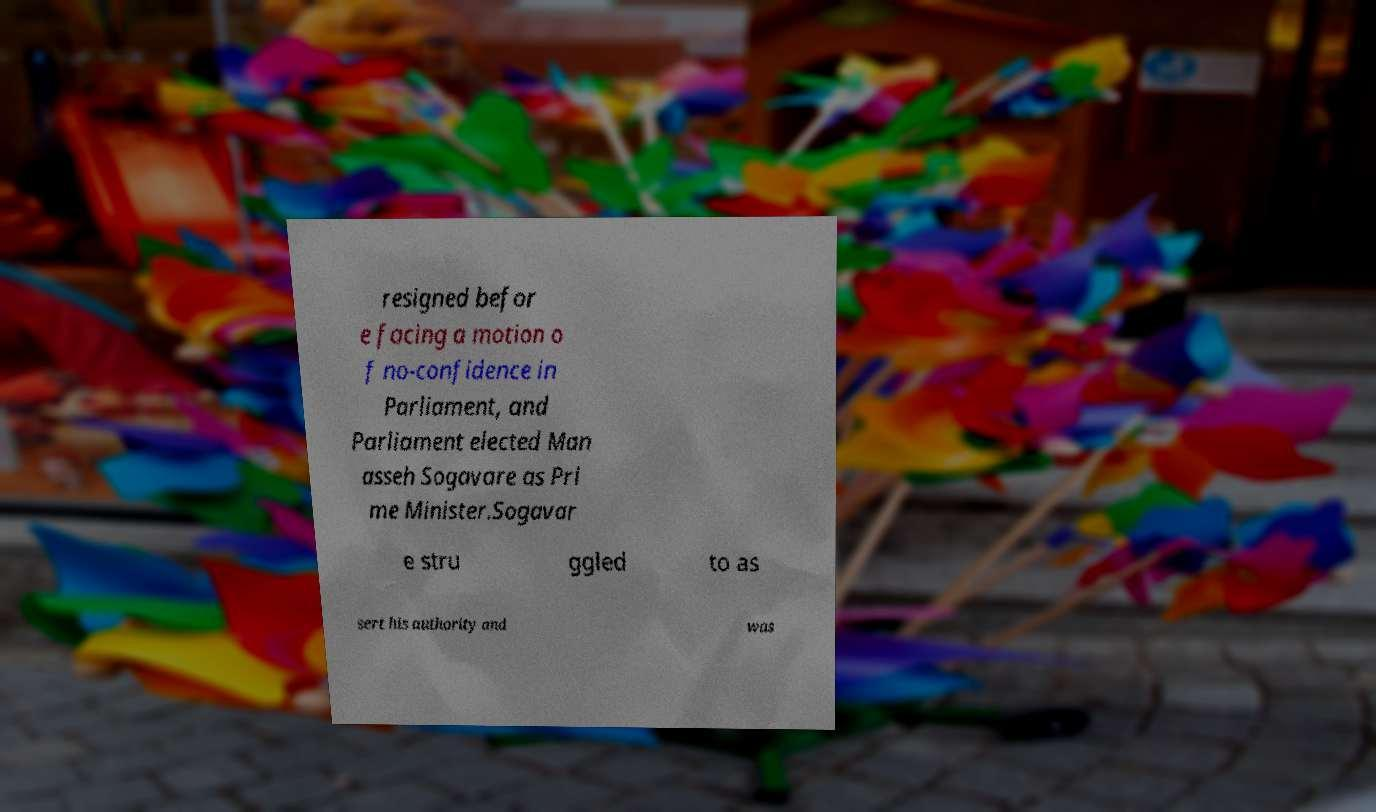Please identify and transcribe the text found in this image. resigned befor e facing a motion o f no-confidence in Parliament, and Parliament elected Man asseh Sogavare as Pri me Minister.Sogavar e stru ggled to as sert his authority and was 